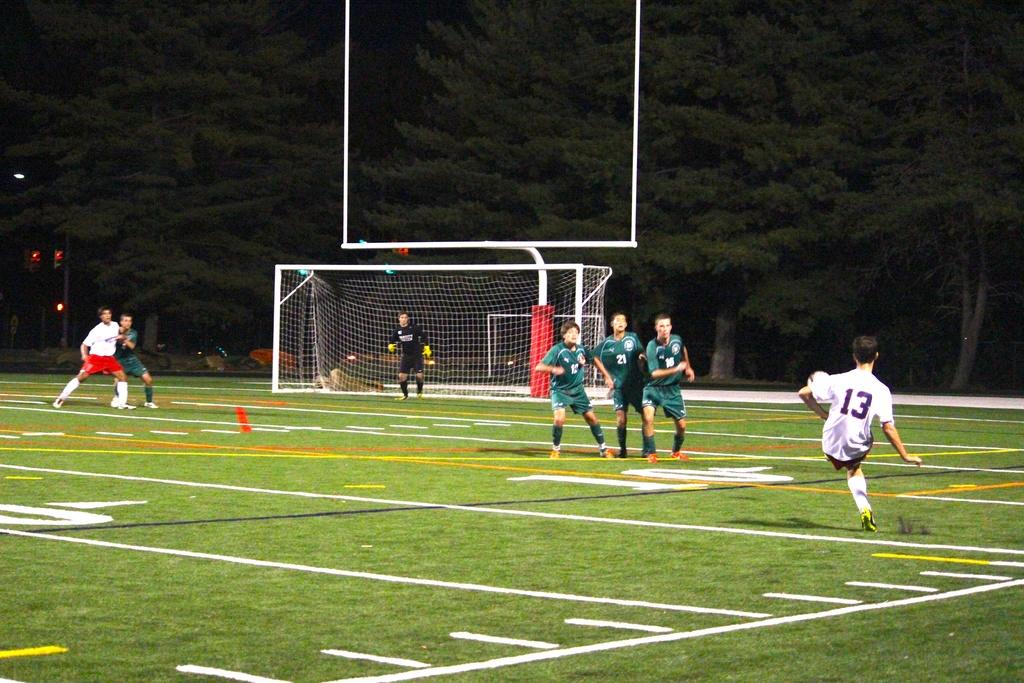What player is on the right?
Offer a very short reply. 13. What is the number of the player in green in the middle of the three in green?
Offer a very short reply. 21. 